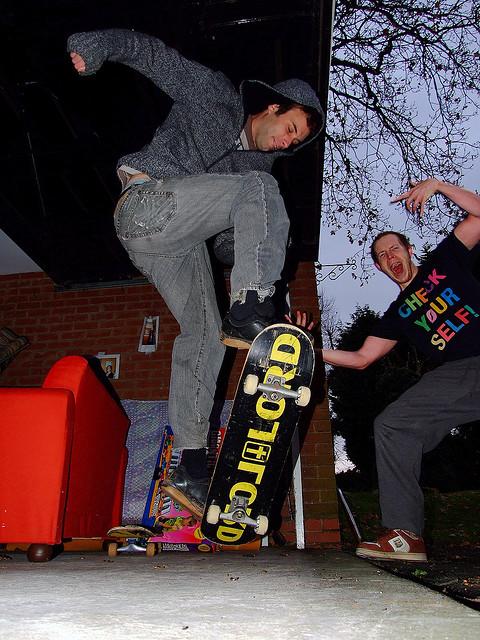What does the T-Shirt of the man not skateboarding say?
Be succinct. Check yourself. What kind of wall is in the background?
Give a very brief answer. Brick. What is the man doing?
Short answer required. Skateboarding. 